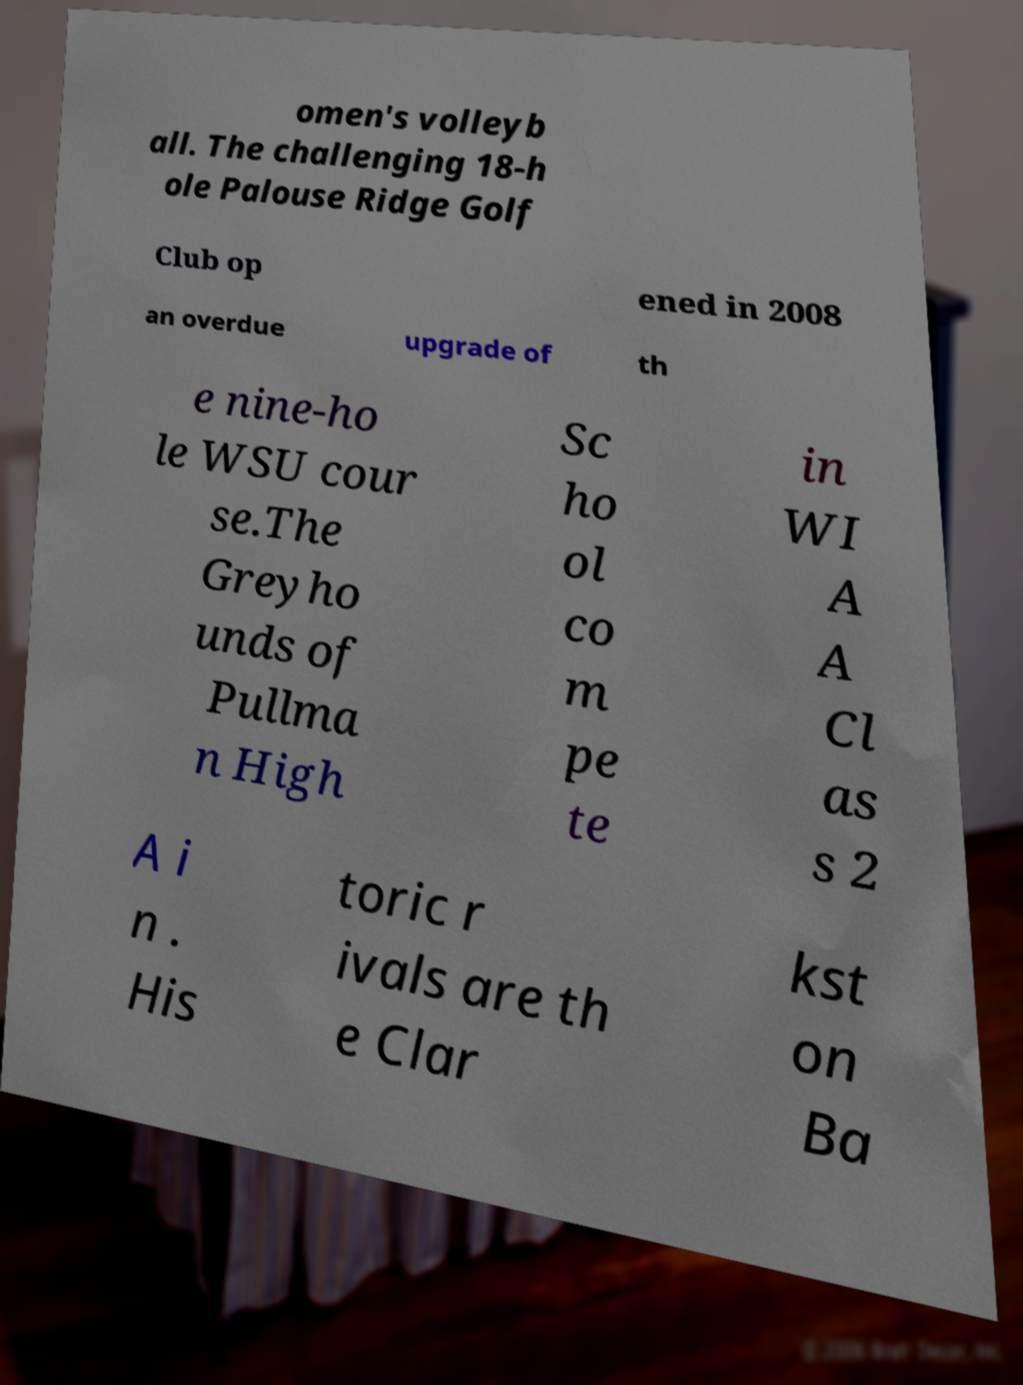Can you read and provide the text displayed in the image?This photo seems to have some interesting text. Can you extract and type it out for me? omen's volleyb all. The challenging 18-h ole Palouse Ridge Golf Club op ened in 2008 an overdue upgrade of th e nine-ho le WSU cour se.The Greyho unds of Pullma n High Sc ho ol co m pe te in WI A A Cl as s 2 A i n . His toric r ivals are th e Clar kst on Ba 